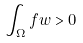<formula> <loc_0><loc_0><loc_500><loc_500>\int _ { \Omega } f w > 0</formula> 